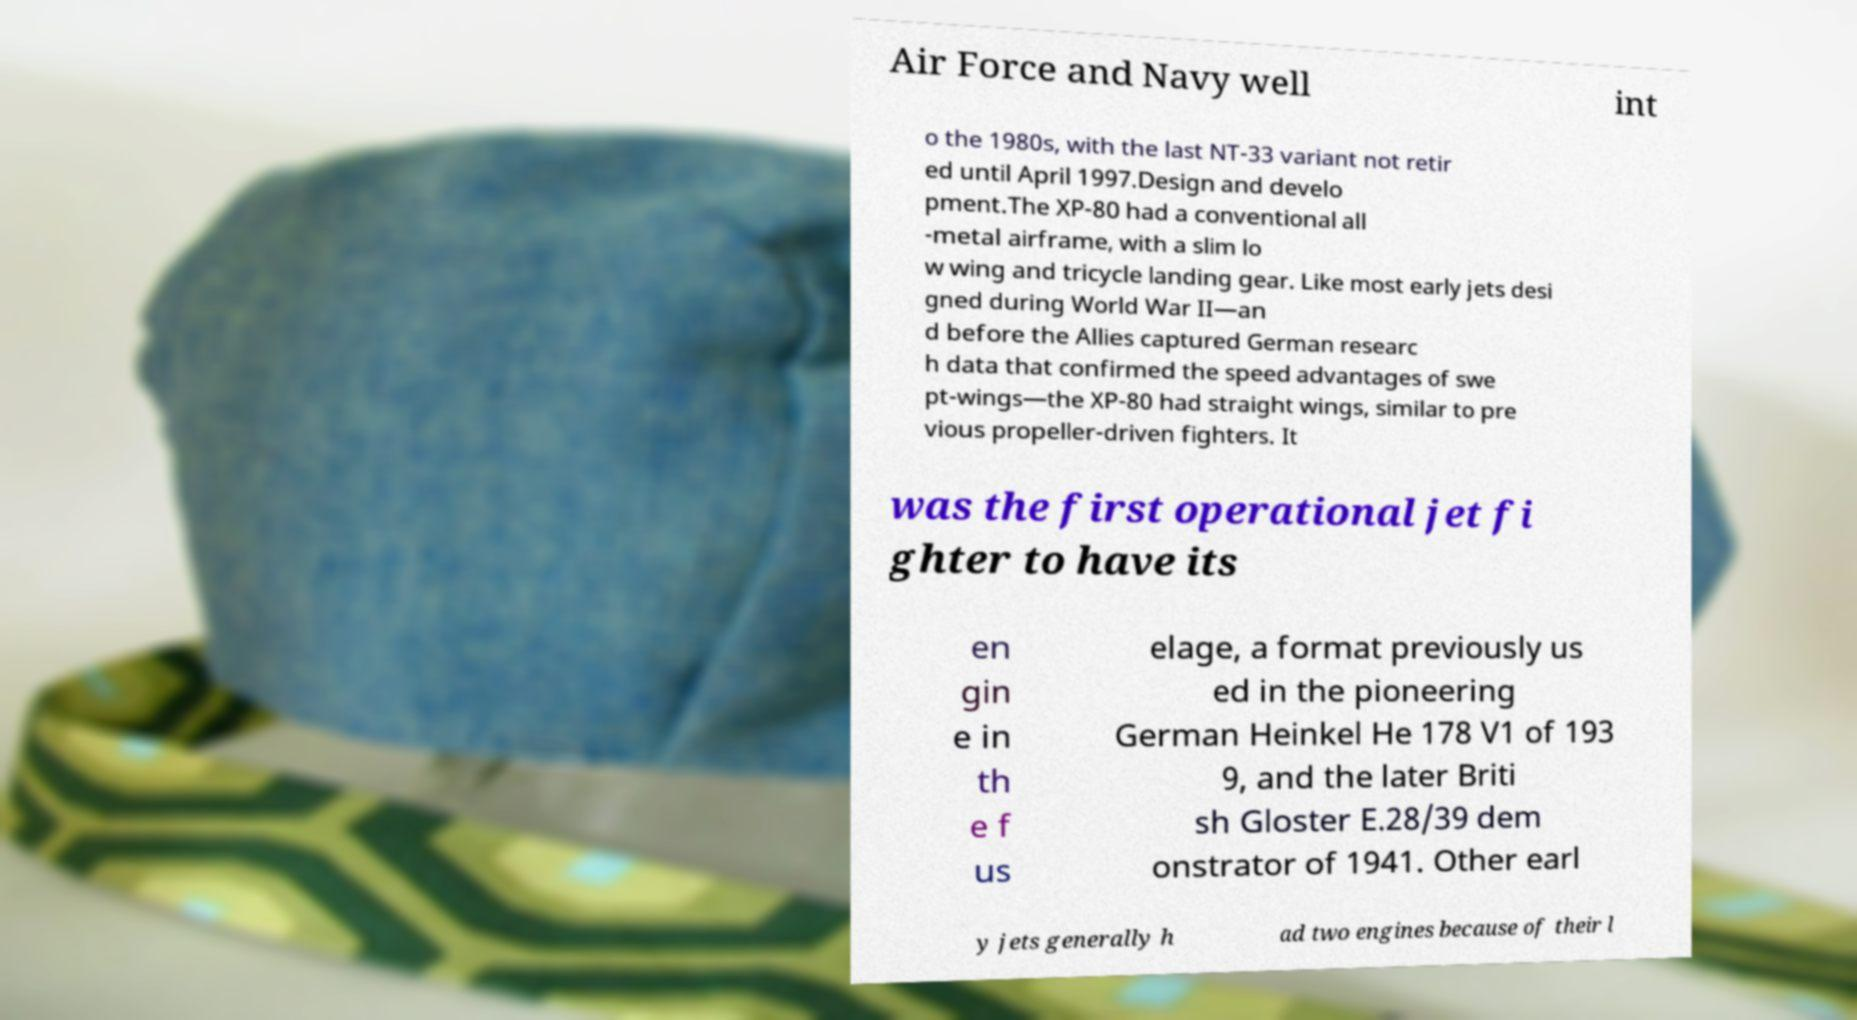Could you assist in decoding the text presented in this image and type it out clearly? Air Force and Navy well int o the 1980s, with the last NT-33 variant not retir ed until April 1997.Design and develo pment.The XP-80 had a conventional all -metal airframe, with a slim lo w wing and tricycle landing gear. Like most early jets desi gned during World War II—an d before the Allies captured German researc h data that confirmed the speed advantages of swe pt-wings—the XP-80 had straight wings, similar to pre vious propeller-driven fighters. It was the first operational jet fi ghter to have its en gin e in th e f us elage, a format previously us ed in the pioneering German Heinkel He 178 V1 of 193 9, and the later Briti sh Gloster E.28/39 dem onstrator of 1941. Other earl y jets generally h ad two engines because of their l 